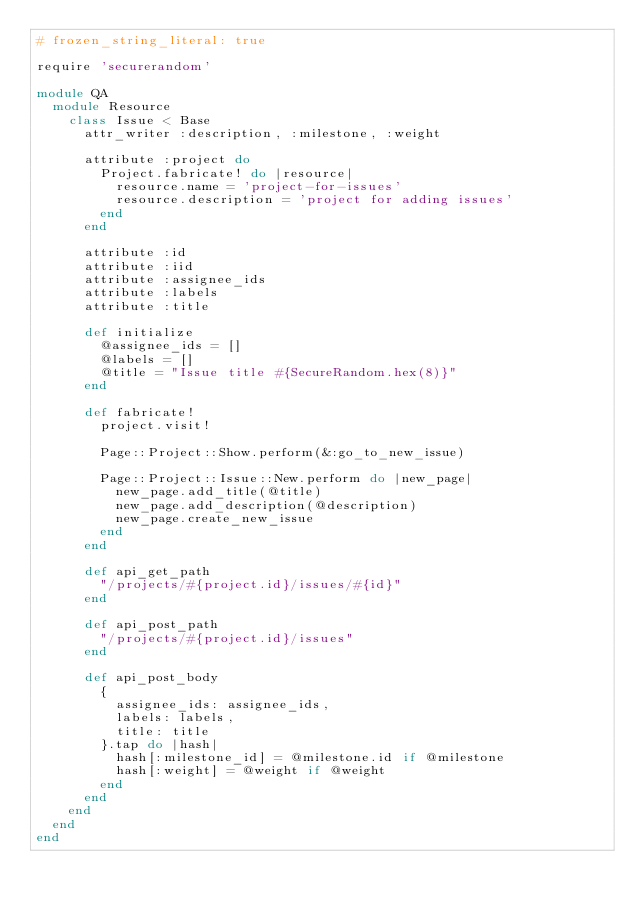Convert code to text. <code><loc_0><loc_0><loc_500><loc_500><_Ruby_># frozen_string_literal: true

require 'securerandom'

module QA
  module Resource
    class Issue < Base
      attr_writer :description, :milestone, :weight

      attribute :project do
        Project.fabricate! do |resource|
          resource.name = 'project-for-issues'
          resource.description = 'project for adding issues'
        end
      end

      attribute :id
      attribute :iid
      attribute :assignee_ids
      attribute :labels
      attribute :title

      def initialize
        @assignee_ids = []
        @labels = []
        @title = "Issue title #{SecureRandom.hex(8)}"
      end

      def fabricate!
        project.visit!

        Page::Project::Show.perform(&:go_to_new_issue)

        Page::Project::Issue::New.perform do |new_page|
          new_page.add_title(@title)
          new_page.add_description(@description)
          new_page.create_new_issue
        end
      end

      def api_get_path
        "/projects/#{project.id}/issues/#{id}"
      end

      def api_post_path
        "/projects/#{project.id}/issues"
      end

      def api_post_body
        {
          assignee_ids: assignee_ids,
          labels: labels,
          title: title
        }.tap do |hash|
          hash[:milestone_id] = @milestone.id if @milestone
          hash[:weight] = @weight if @weight
        end
      end
    end
  end
end
</code> 